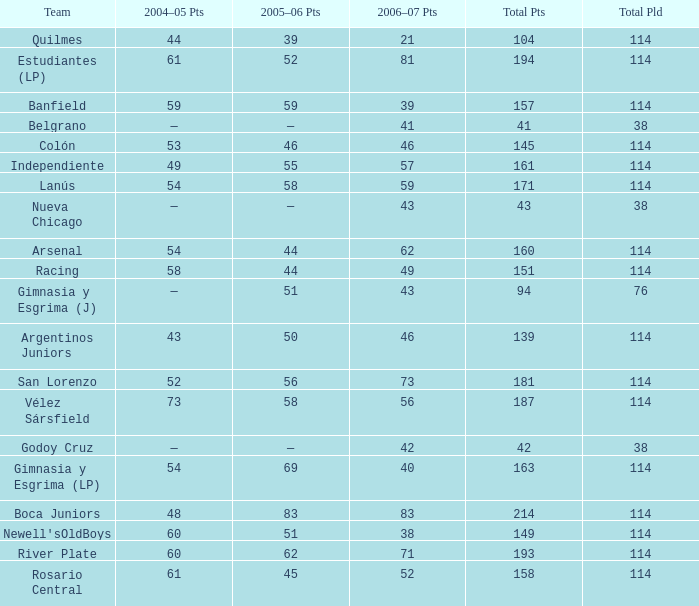What is the average total pld with 45 points in 2005-06, and more than 52 points in 2006-07? None. 